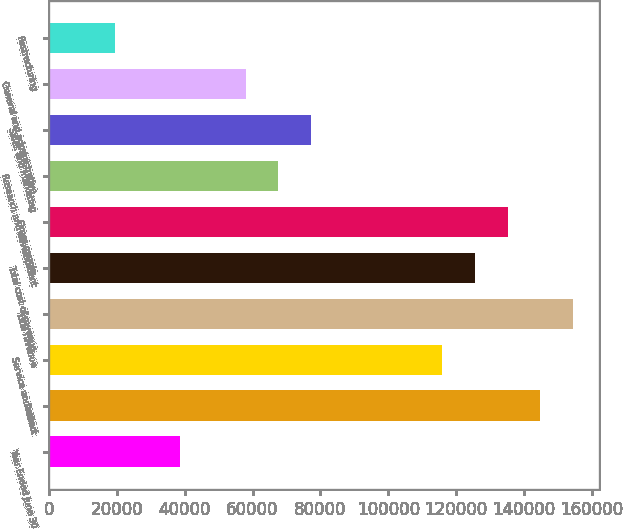<chart> <loc_0><loc_0><loc_500><loc_500><bar_chart><fcel>Year Ended June 30<fcel>Product<fcel>Service and other<fcel>Total revenue<fcel>Total cost of revenue<fcel>Gross margin<fcel>Research and development<fcel>Sales and marketing<fcel>General and administrative<fcel>Restructuring<nl><fcel>38630.3<fcel>144855<fcel>115885<fcel>154512<fcel>125541<fcel>135198<fcel>67600.7<fcel>77257.4<fcel>57943.9<fcel>19316.8<nl></chart> 